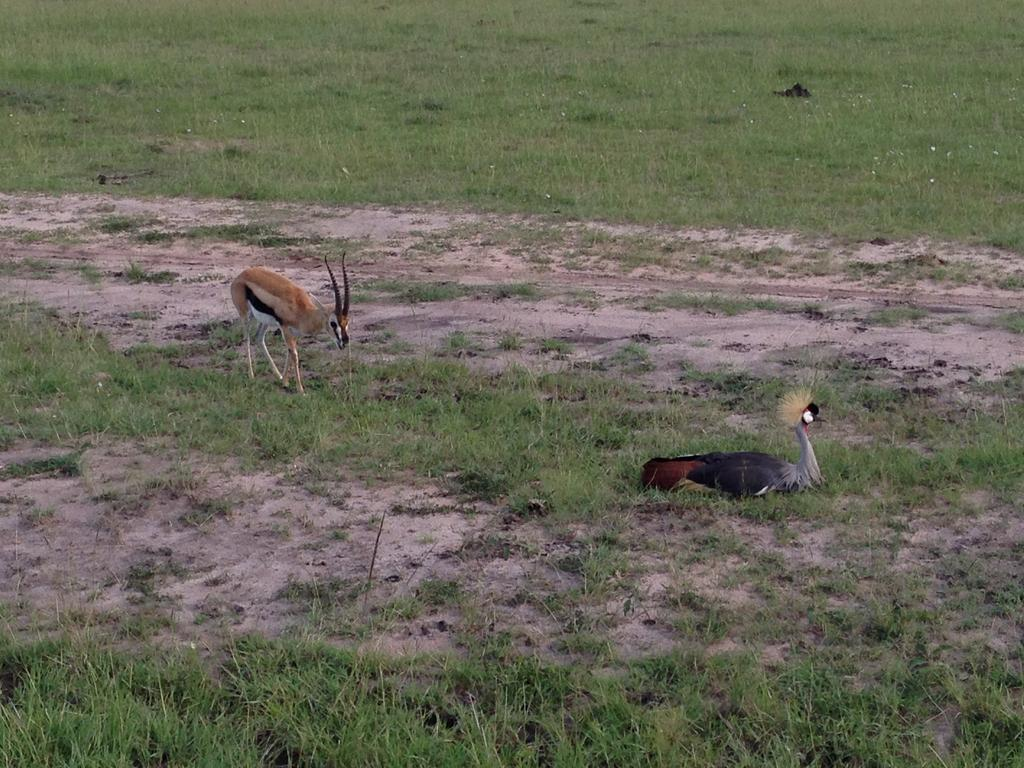What type of animal can be seen in the image? There is a deer in the image. What other living creature is present in the image? There is a bird in the image. What type of vegetation is visible in the image? There is grass visible in the image. How many cars are parked next to the deer in the image? There are no cars present in the image; it features a deer and a bird in a natural setting. What word is written on the bird's wing in the image? There are no words written on the bird's wing in the image; it is a natural bird without any text or markings. 